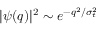<formula> <loc_0><loc_0><loc_500><loc_500>| \psi ( q ) | ^ { 2 } \sim e ^ { - q ^ { 2 } / \sigma _ { t } ^ { 2 } }</formula> 